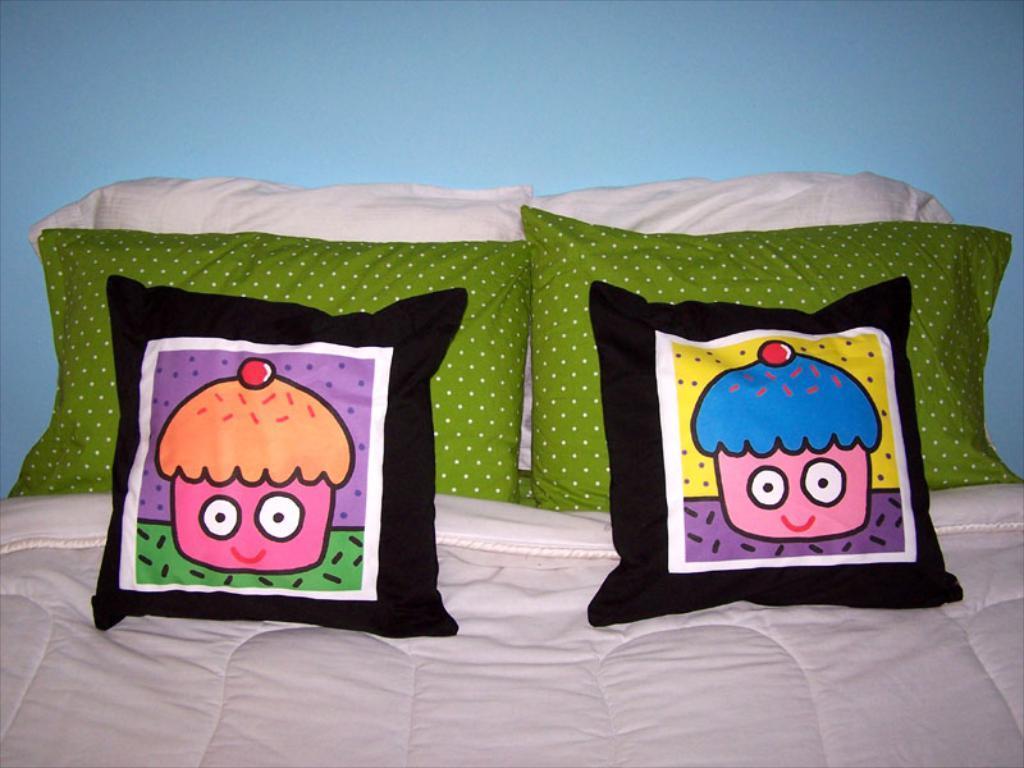Describe this image in one or two sentences. In this picture we can see pillows on bed. In the background of the image it is blue. 